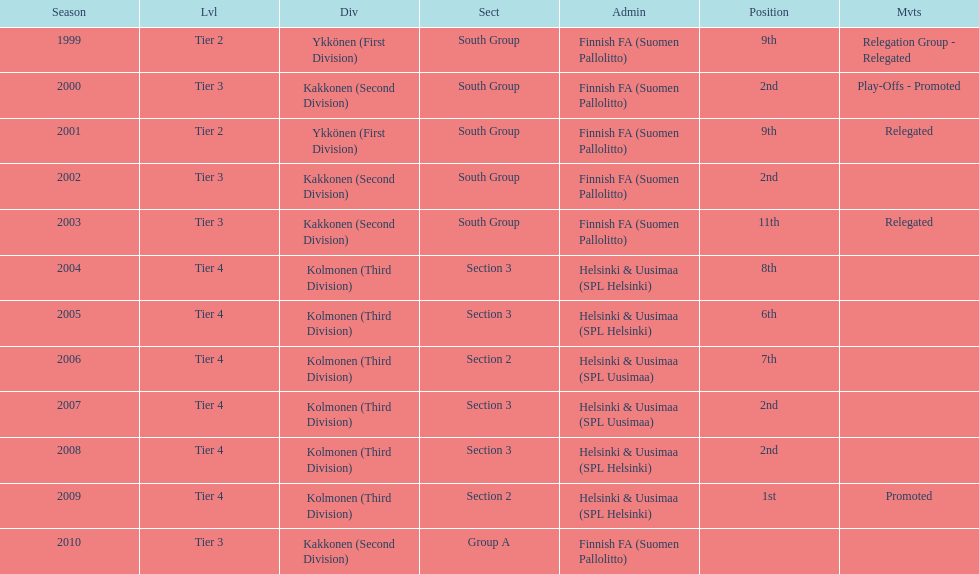How many times has this team been relegated? 3. 